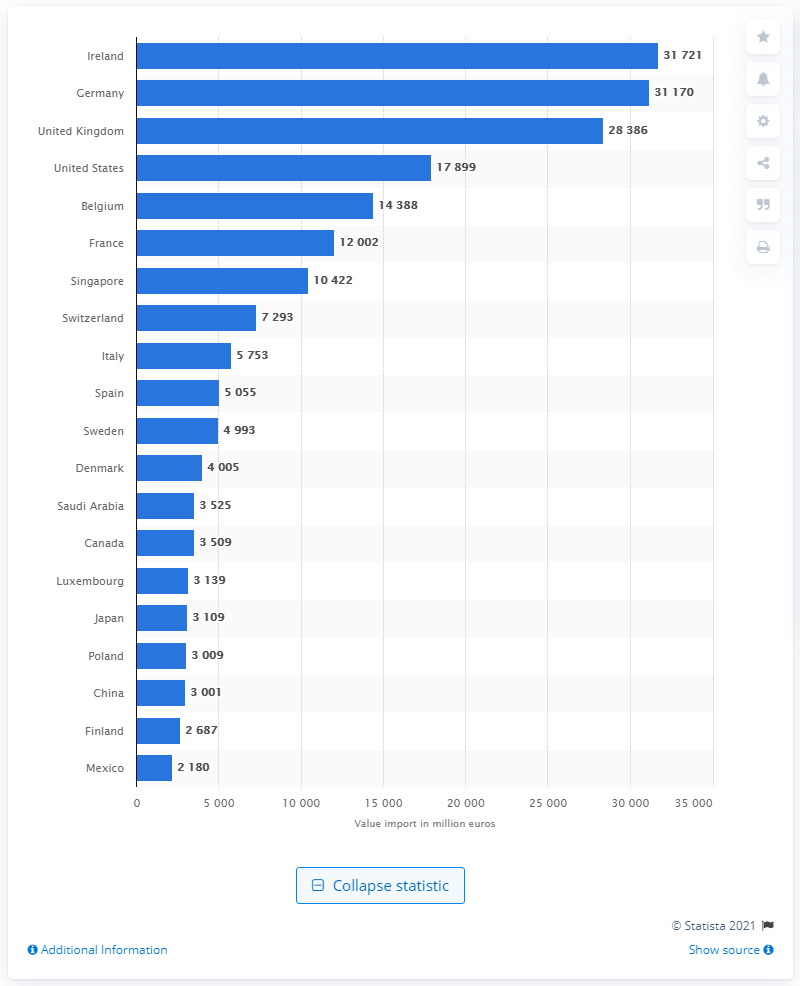Can you point out which countries have a service export value under 4,000 million euros? Several countries have service export values under 4,000 million euros including Luxembourg (3,139 million euros), Japan (3,109 million euros), Poland (3,009 million euros), China (3,001 million euros), and Mexico (2,180 million euros). 